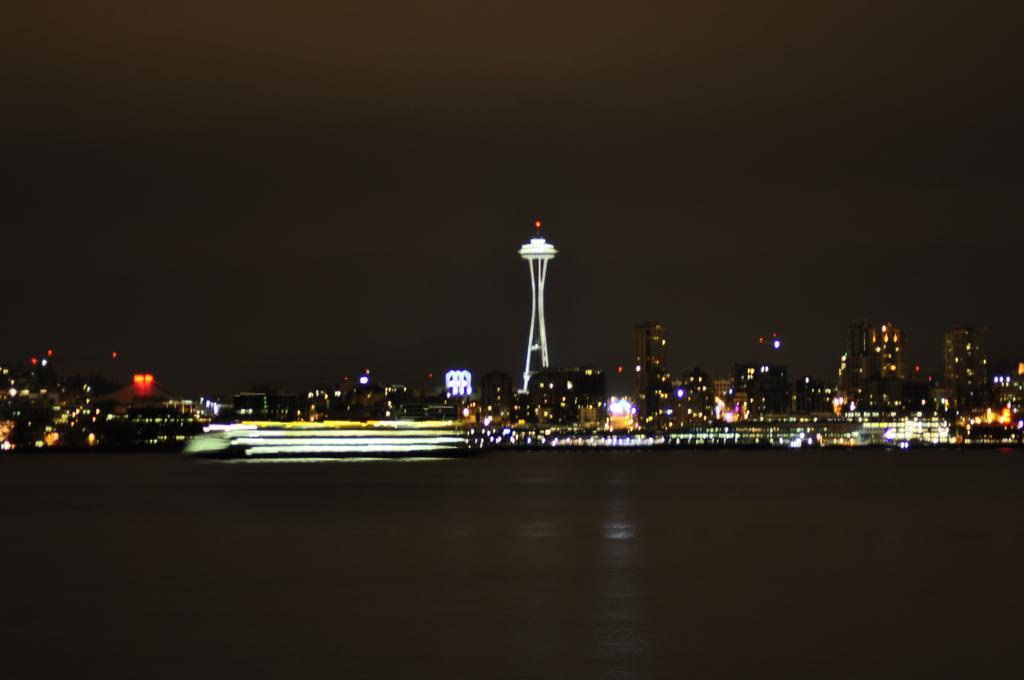Please provide a concise description of this image. In this image we can see buildings, towers, skyscrapers, electric lights, water and sky. 